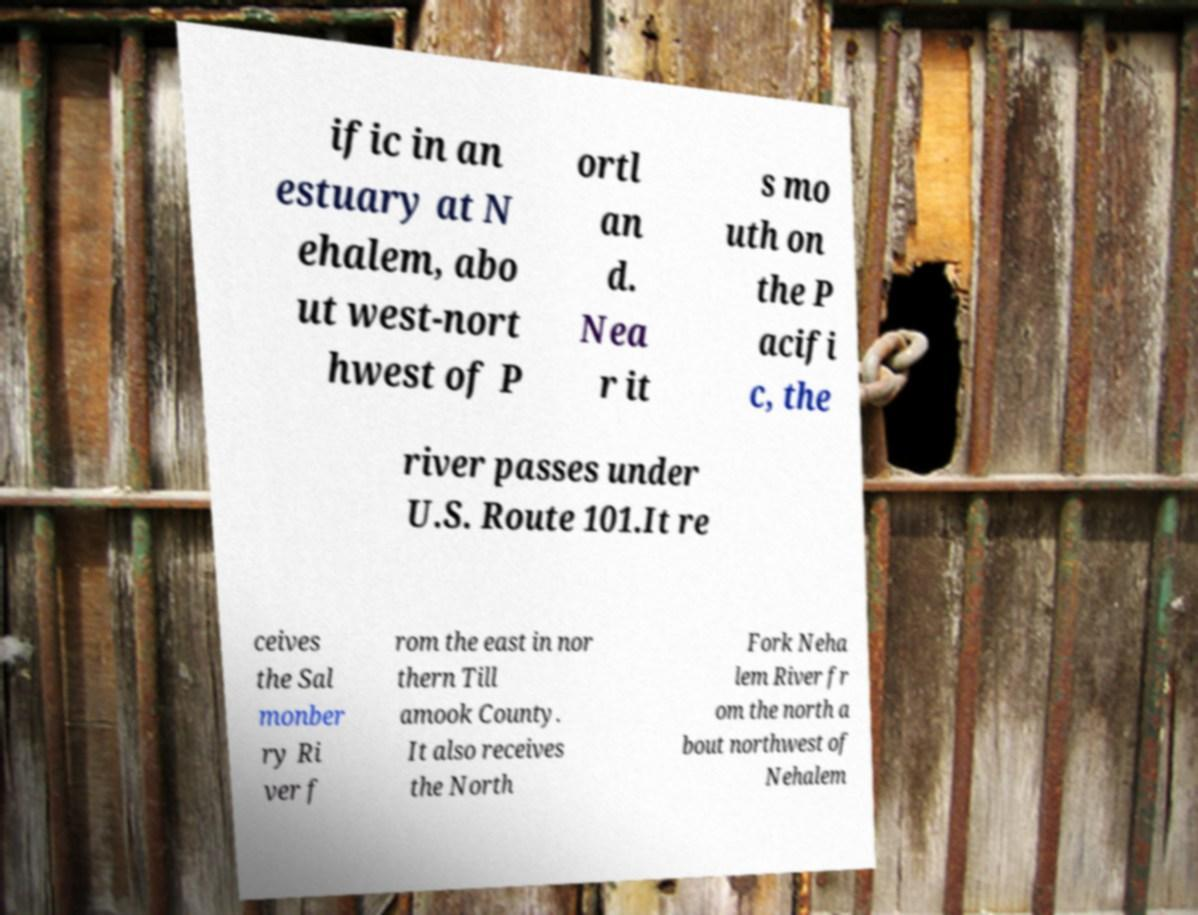I need the written content from this picture converted into text. Can you do that? ific in an estuary at N ehalem, abo ut west-nort hwest of P ortl an d. Nea r it s mo uth on the P acifi c, the river passes under U.S. Route 101.It re ceives the Sal monber ry Ri ver f rom the east in nor thern Till amook County. It also receives the North Fork Neha lem River fr om the north a bout northwest of Nehalem 